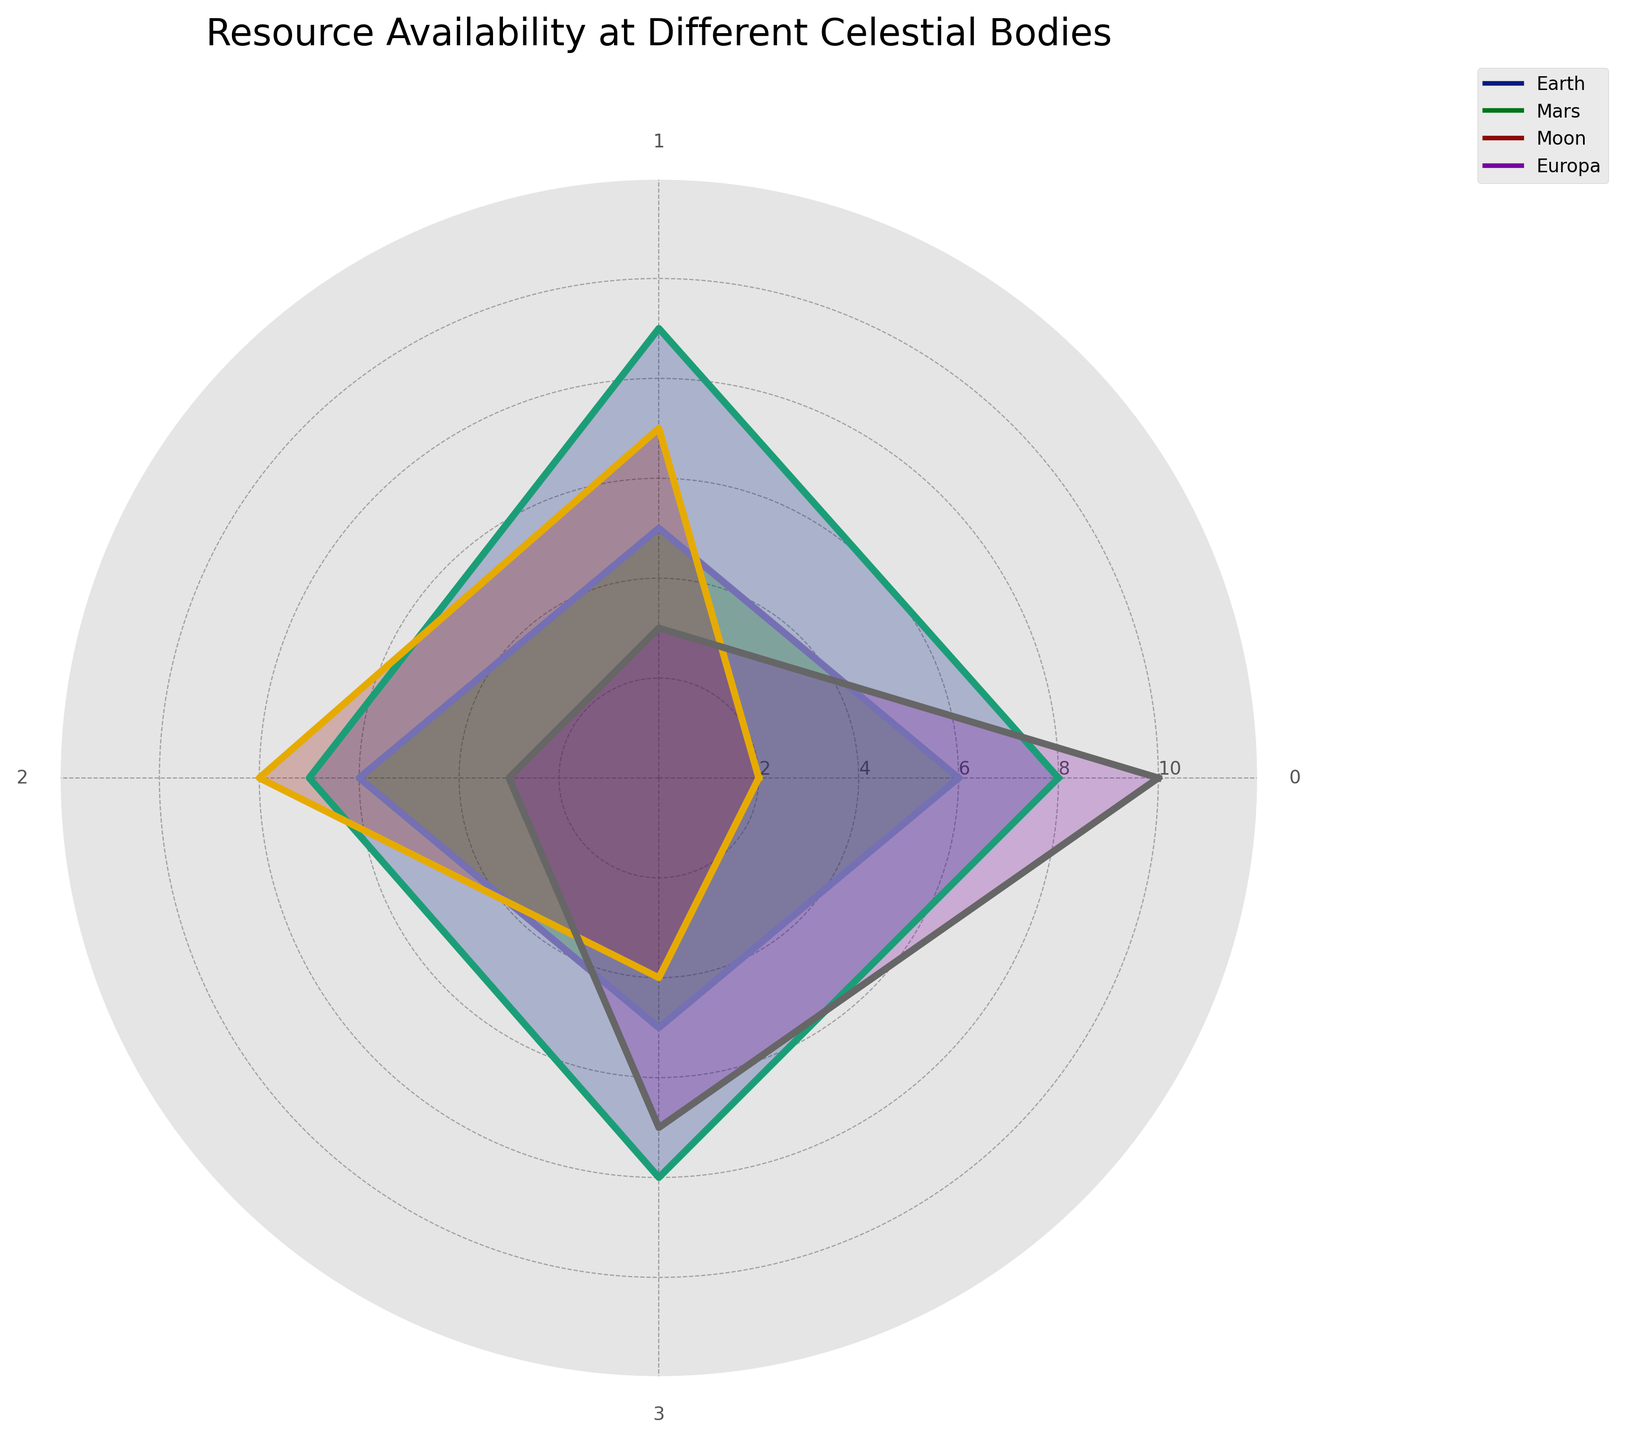What is the title of the radar chart? The title is usually prominently displayed at the top or above the plot area. In this case, it is clearly stated at the top.
Answer: Resource Availability at Different Celestial Bodies Which celestial body has the highest availability of water? To determine this, look at the value of water for each celestial body. Europa has a value of 10, which is the highest.
Answer: Europa Which resource has the lowest availability on the Moon? By examining the values associated with the Moon, the lowest value is 2 for water.
Answer: Water How does the availability of minerals on Mars compare to that on Earth? Look at the values for minerals on both Mars and Earth. Mars has a value of 5, while Earth has a value of 9, indicating Earth has higher availability.
Answer: Earth has higher availability What is the average availability of solar energy across all celestial bodies? The solar energy values are Earth (7), Mars (6), Moon (8), Europa (3). Calculate the average: (7 + 6 + 8 + 3) / 4 = 24 / 4 = 6.
Answer: 6 Between Earth and Mars, which has a higher overall resource availability? Compare the values for each resource (water, minerals, solar energy, hydrogen) on Earth and Mars. Sum them up: Earth (8+9+7+8=32), Mars (6+5+6+5=22). Earth has a higher total.
Answer: Earth Which celestial body has the most balanced resource availability across all resources? A balanced availability would have similar values for all categories. The Moon's values (2, 7, 8, 4) are relatively close together compared to other celestial bodies.
Answer: Moon What is the difference in hydrogen availability between Europa and Mars? The values for hydrogen are Europa (7) and Mars (5). The difference is 7 - 5 = 2.
Answer: 2 Rank the celestial bodies by their availability of solar energy from highest to lowest. Compare each celestial body’s value for solar energy: Moon (8), Earth (7), Mars (6), Europa (3).
Answer: Moon, Earth, Mars, Europa Which celestial body has the lowest overall resource availability? Sum up the values for each celestial body: Earth (32), Mars (22), Moon (21), Europa (23). The Moon has the lowest total of 21.
Answer: Moon 